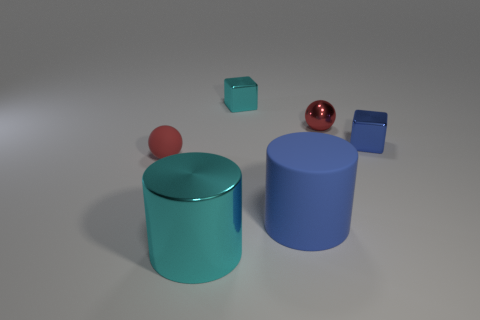Add 2 blue things. How many objects exist? 8 Subtract 2 cylinders. How many cylinders are left? 0 Subtract all spheres. How many objects are left? 4 Add 5 green spheres. How many green spheres exist? 5 Subtract 0 cyan balls. How many objects are left? 6 Subtract all gray spheres. Subtract all purple cubes. How many spheres are left? 2 Subtract all tiny red metallic balls. Subtract all large rubber cylinders. How many objects are left? 4 Add 5 small rubber things. How many small rubber things are left? 6 